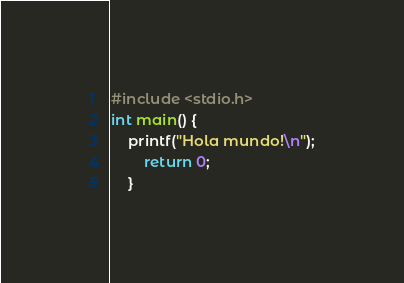Convert code to text. <code><loc_0><loc_0><loc_500><loc_500><_C_>#include <stdio.h>
int main() {
	printf("Hola mundo!\n");
		return 0;
	}</code> 